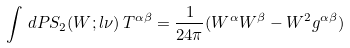<formula> <loc_0><loc_0><loc_500><loc_500>\int \, d P S _ { 2 } ( W ; l \nu ) \, T ^ { \alpha \beta } = \frac { 1 } { 2 4 \pi } ( W ^ { \alpha } W ^ { \beta } - W ^ { 2 } g ^ { \alpha \beta } )</formula> 